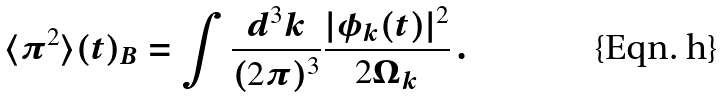Convert formula to latex. <formula><loc_0><loc_0><loc_500><loc_500>\langle \pi ^ { 2 } \rangle ( t ) _ { B } = \int \frac { d ^ { 3 } k } { ( 2 \pi ) ^ { 3 } } \frac { | \phi _ { k } ( t ) | ^ { 2 } } { 2 \Omega _ { k } } \, .</formula> 